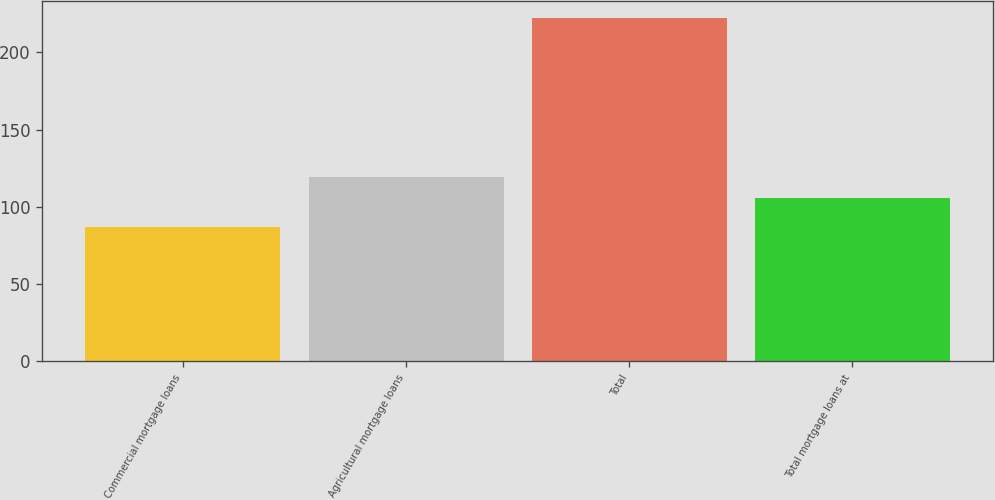Convert chart to OTSL. <chart><loc_0><loc_0><loc_500><loc_500><bar_chart><fcel>Commercial mortgage loans<fcel>Agricultural mortgage loans<fcel>Total<fcel>Total mortgage loans at<nl><fcel>87<fcel>119.5<fcel>222<fcel>106<nl></chart> 